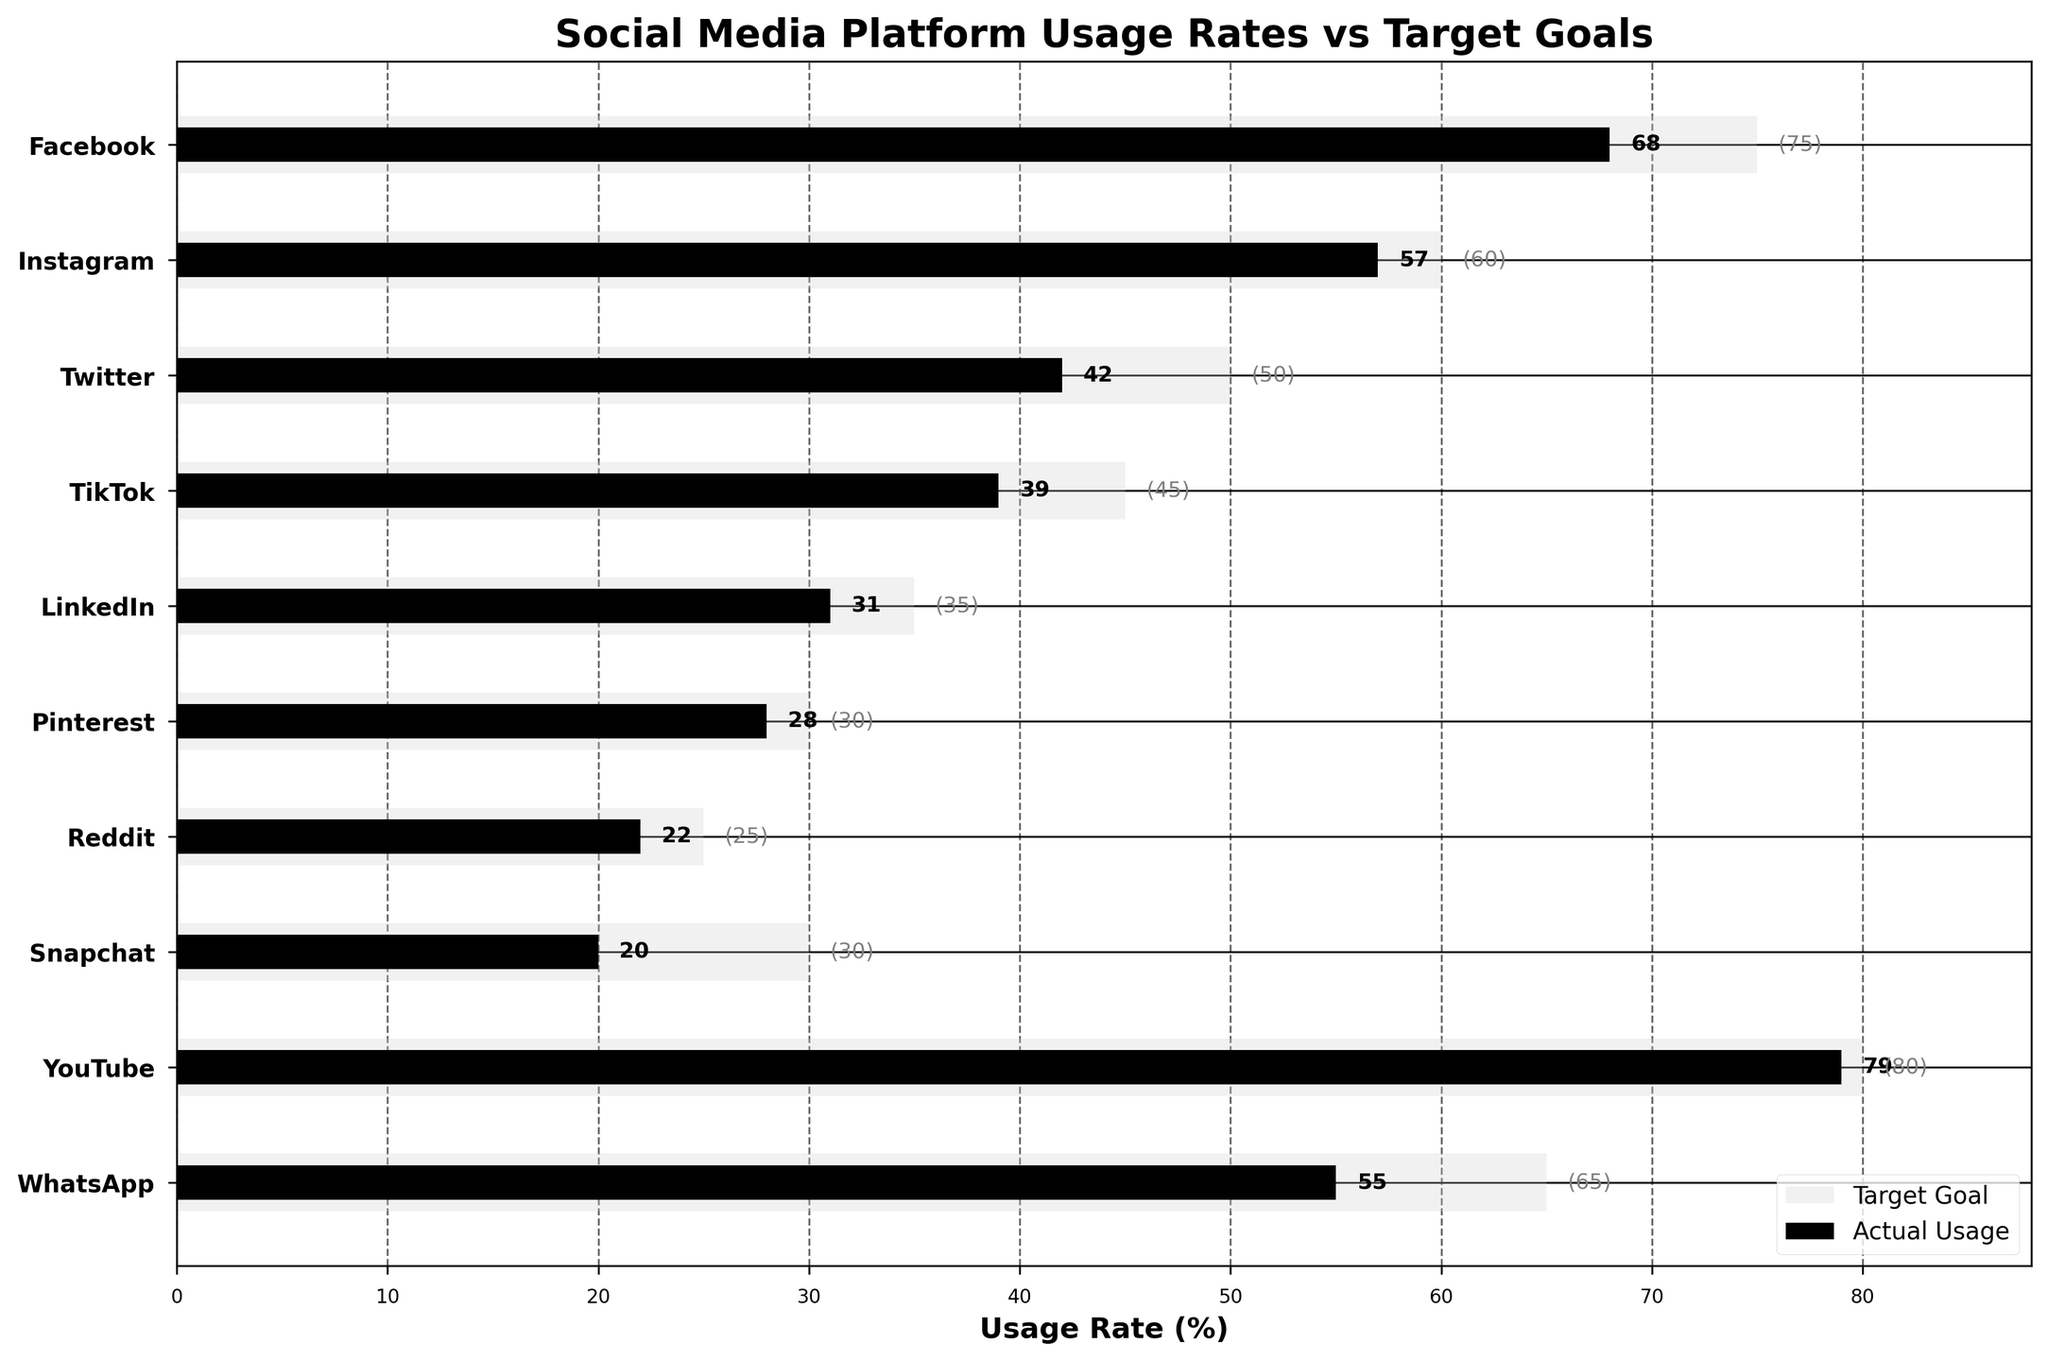What's the title of the chart? The title is typically displayed at the top of the chart and provides a summary of the data being visualized. In this chart, the title gives an idea of what the viewer is looking at.
Answer: Social Media Platform Usage Rates vs Target Goals What is the actual usage rate of LinkedIn? To find this, look for the bar associated with LinkedIn on the chart. The actual usage rate is the value indicated by the shorter bar.
Answer: 31 Which social media platform has the highest actual usage rate? Find the longest actual usage rate bar among the platforms. Looking at the chart, the platform with the longest black bar is the one with the highest usage rate.
Answer: YouTube How far below the target goal is Snapchat's actual usage rate? For this, subtract Snapchat's actual usage rate from its target goal. The chart shows that Snapchat's target is 30% and its actual usage is 20%.
Answer: 10 Which platform is closest to reaching its target goal? Determine the difference between the actual and target usage rates for each platform and find the smallest difference. Looking at the chart, the platform with the smallest gap between the black and light gray bars is the closest.
Answer: YouTube What is the total combined actual usage rate of Facebook, Instagram, and Twitter? Add the actual usage rates of Facebook, Instagram, and Twitter. These values are 68, 57, and 42, respectively. 68 + 57 + 42 = 167
Answer: 167 What is the average target goal across all platforms? Sum all the target goals and divide by the number of platforms (10). The target goals are: 75, 60, 50, 45, 35, 30, 25, 30, 80, and 65. The sum is 75 + 60 + 50 + 45 + 35 + 30 + 25 + 30 + 80 + 65 = 495, so the average is 495 / 10 = 49.5
Answer: 49.5 Which platform has the largest difference between actual usage and target goal? Subtract each platform's actual usage rate from its target goal and identify the largest difference. For example, for Facebook, it's 75 - 68 = 7. Perform this calculation for all platforms and compare.
Answer: WhatsApp What percentage of platforms have actual usage rates below 50%? Count the number of platforms with actual usage rates below 50% and divide by the total number of platforms (10). Platforms below 50% are Twitter, TikTok, LinkedIn, Pinterest, Reddit, Snapchat, and WhatsApp. 7 / 10 = 0.7 or 70%
Answer: 70% Which platform has an actual usage rate that's less than half of its target goal? Identify the platforms where the actual usage rate is less than half of the target goal by comparing each platform's actual usage rate to half of its target goal. For example, for Snapchat, the actual usage rate is 20 and half of the target goal is 15 (30/2). Verify this for each platform and see which satisfies the condition.
Answer: Snapchat 